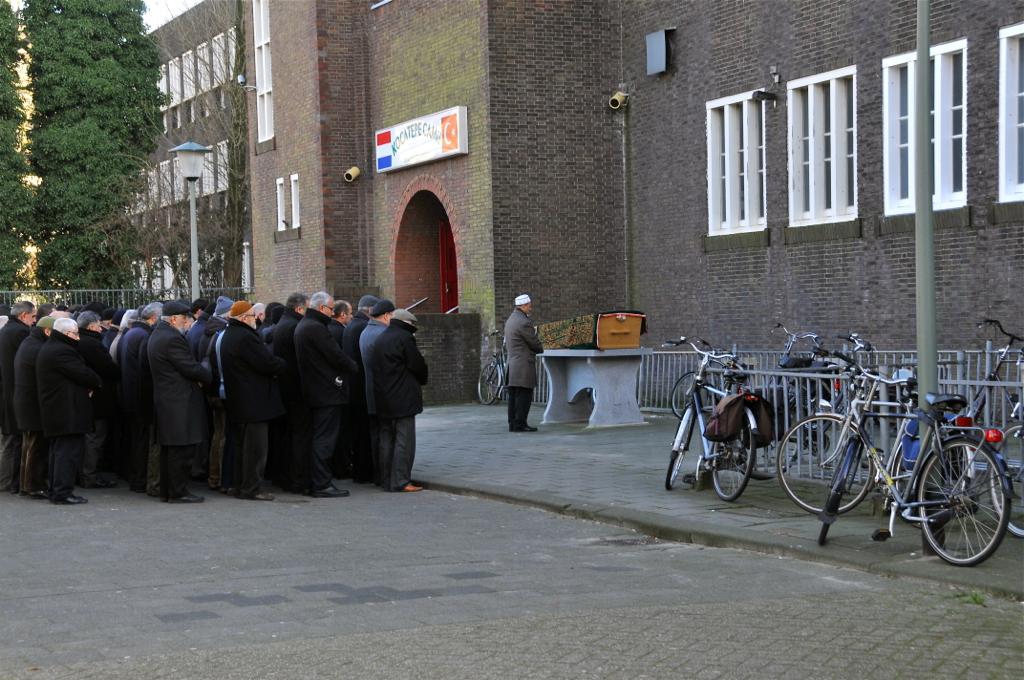Please provide a concise description of this image. In this image on the left side there are a group of people who are standing, and on the right side there are some buildings, windows, and some cycles and a railing. At the bottom there is a road, and in the background there are some trees, pole and light. On the left side there is one pole and in the center there is one box on a table. 